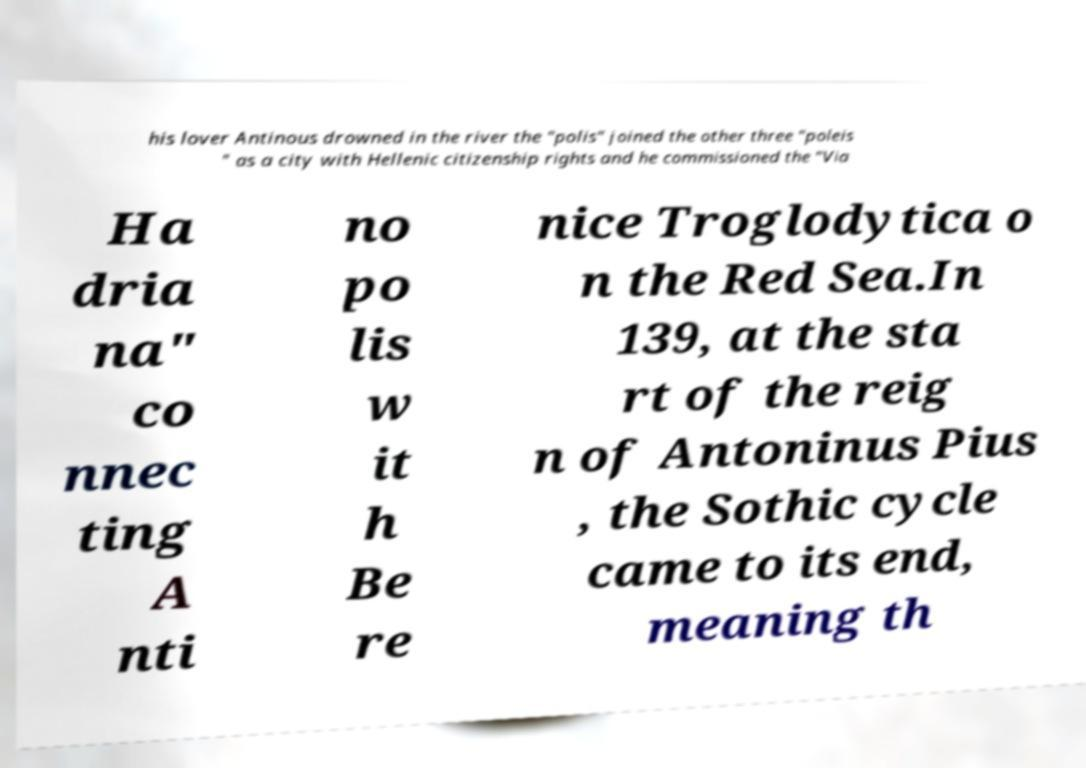Please read and relay the text visible in this image. What does it say? his lover Antinous drowned in the river the "polis" joined the other three "poleis " as a city with Hellenic citizenship rights and he commissioned the "Via Ha dria na" co nnec ting A nti no po lis w it h Be re nice Troglodytica o n the Red Sea.In 139, at the sta rt of the reig n of Antoninus Pius , the Sothic cycle came to its end, meaning th 